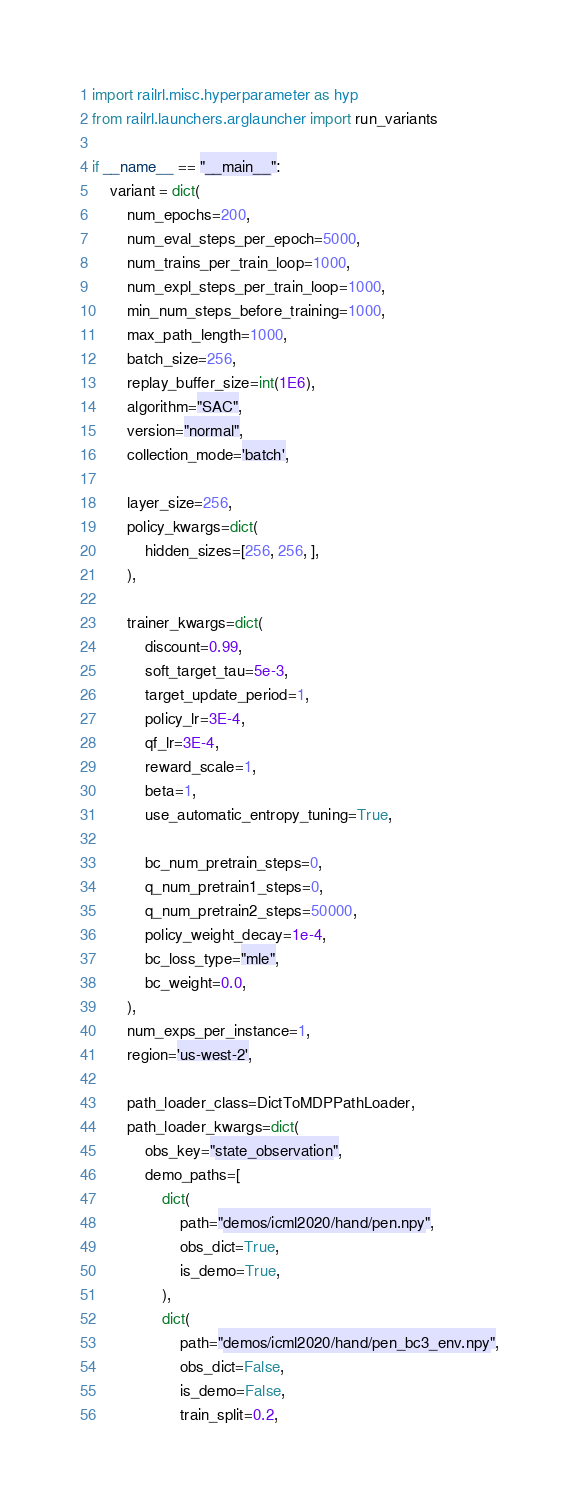Convert code to text. <code><loc_0><loc_0><loc_500><loc_500><_Python_>
import railrl.misc.hyperparameter as hyp
from railrl.launchers.arglauncher import run_variants

if __name__ == "__main__":
    variant = dict(
        num_epochs=200,
        num_eval_steps_per_epoch=5000,
        num_trains_per_train_loop=1000,
        num_expl_steps_per_train_loop=1000,
        min_num_steps_before_training=1000,
        max_path_length=1000,
        batch_size=256,
        replay_buffer_size=int(1E6),
        algorithm="SAC",
        version="normal",
        collection_mode='batch',

        layer_size=256,
        policy_kwargs=dict(
            hidden_sizes=[256, 256, ],
        ),

        trainer_kwargs=dict(
            discount=0.99,
            soft_target_tau=5e-3,
            target_update_period=1,
            policy_lr=3E-4,
            qf_lr=3E-4,
            reward_scale=1,
            beta=1,
            use_automatic_entropy_tuning=True,

            bc_num_pretrain_steps=0,
            q_num_pretrain1_steps=0,
            q_num_pretrain2_steps=50000,
            policy_weight_decay=1e-4,
            bc_loss_type="mle",
            bc_weight=0.0,
        ),
        num_exps_per_instance=1,
        region='us-west-2',

        path_loader_class=DictToMDPPathLoader,
        path_loader_kwargs=dict(
            obs_key="state_observation",
            demo_paths=[
                dict(
                    path="demos/icml2020/hand/pen.npy",
                    obs_dict=True,
                    is_demo=True,
                ),
                dict(
                    path="demos/icml2020/hand/pen_bc3_env.npy",
                    obs_dict=False,
                    is_demo=False,
                    train_split=0.2,</code> 